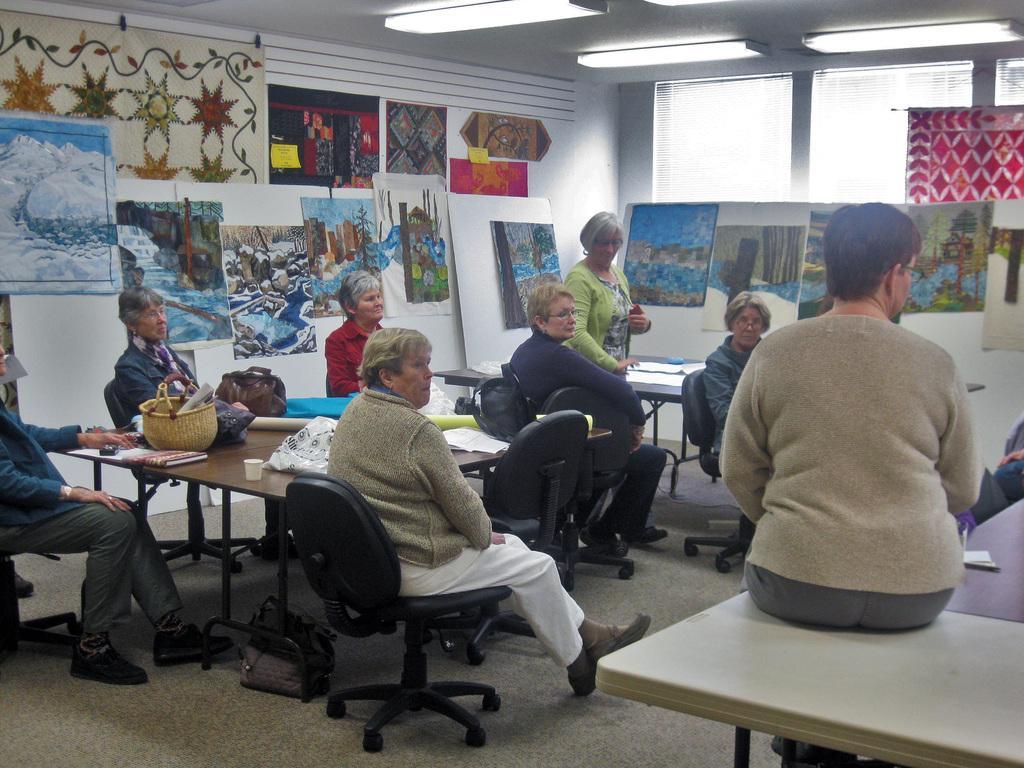Can you describe this image briefly? In the middle of the image there are some chairs and tables and there are some persons are sitting on chairs. Top left side of the image there is a wall, On the wall there are some posters. At the top of the image there is roof and lights. 